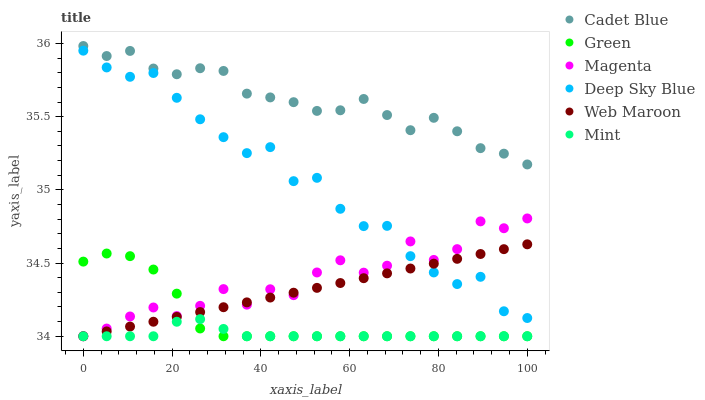Does Mint have the minimum area under the curve?
Answer yes or no. Yes. Does Cadet Blue have the maximum area under the curve?
Answer yes or no. Yes. Does Web Maroon have the minimum area under the curve?
Answer yes or no. No. Does Web Maroon have the maximum area under the curve?
Answer yes or no. No. Is Web Maroon the smoothest?
Answer yes or no. Yes. Is Magenta the roughest?
Answer yes or no. Yes. Is Green the smoothest?
Answer yes or no. No. Is Green the roughest?
Answer yes or no. No. Does Web Maroon have the lowest value?
Answer yes or no. Yes. Does Deep Sky Blue have the lowest value?
Answer yes or no. No. Does Cadet Blue have the highest value?
Answer yes or no. Yes. Does Web Maroon have the highest value?
Answer yes or no. No. Is Green less than Cadet Blue?
Answer yes or no. Yes. Is Cadet Blue greater than Deep Sky Blue?
Answer yes or no. Yes. Does Magenta intersect Deep Sky Blue?
Answer yes or no. Yes. Is Magenta less than Deep Sky Blue?
Answer yes or no. No. Is Magenta greater than Deep Sky Blue?
Answer yes or no. No. Does Green intersect Cadet Blue?
Answer yes or no. No. 